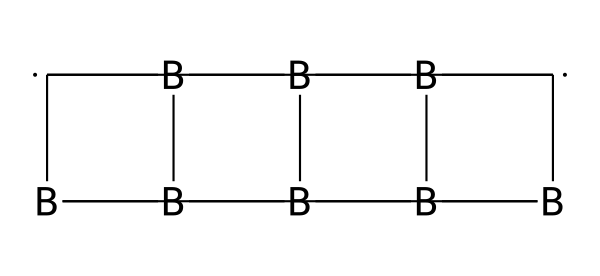What is the main element present in the chemical structure? The chemical structure includes boron and carbon atoms; however, boron is more prevalent in the cage compounds.
Answer: boron How many carbon atoms are present in this compound? Analyzing the SMILES, there are two carbon atoms indicated in the structure's connectivity.
Answer: 2 What kind of bonding is primarily observed in this structure? The structure mainly consists of covalent bonds between the boron and carbon atoms, typical for cage compounds.
Answer: covalent What type of structure do carboranes exhibit? Carboranes have a three-dimensional polyhedral structure characterized by the arrangement of boron and carbon atoms in a cage formation.
Answer: cage What property of carboranes makes them suitable for fire-resistant materials? The boron atoms in the cage-like structure enhance thermal stability and flame resistance, making these compounds ideal for such applications.
Answer: thermal stability What is the relationship between the number of boron atoms and the stability of the compound? The presence of more boron atoms typically enhances the structural stability due to the boron's flexibility and bonding characteristics in three-dimensional arrangements.
Answer: enhances stability How many total atoms are present in this carborane compound? By examining the SMILES representation, we find a total of six boron atoms and two carbon atoms, indicating a total of eight atoms in this compound.
Answer: 8 